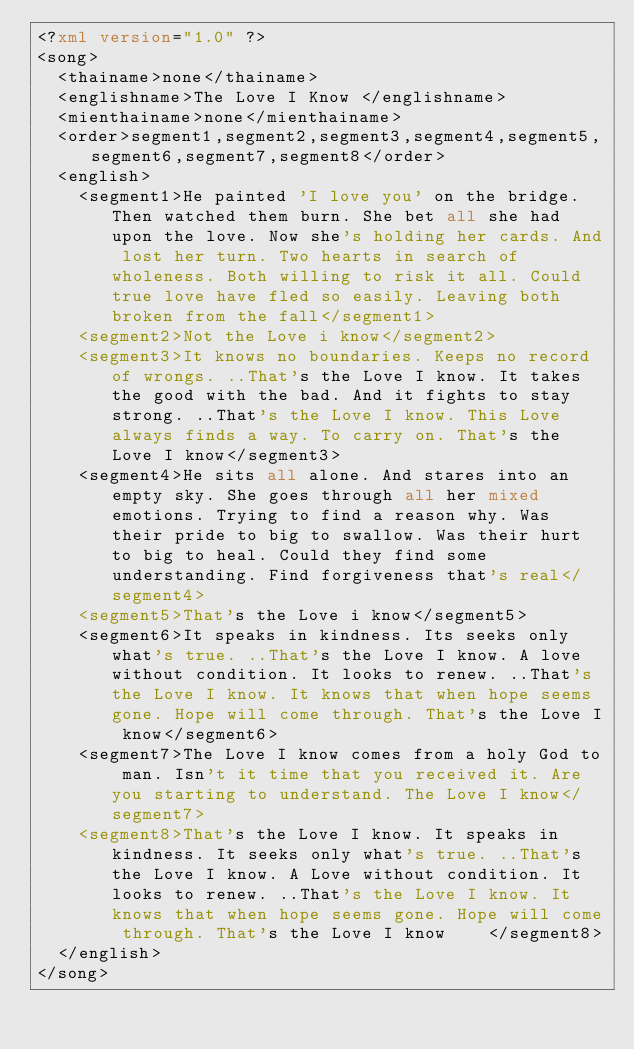Convert code to text. <code><loc_0><loc_0><loc_500><loc_500><_XML_><?xml version="1.0" ?>
<song>
	<thainame>none</thainame>
	<englishname>The Love I Know </englishname>
	<mienthainame>none</mienthainame>
	<order>segment1,segment2,segment3,segment4,segment5,segment6,segment7,segment8</order>
	<english>
		<segment1>He painted 'I love you' on the bridge. Then watched them burn. She bet all she had upon the love. Now she's holding her cards. And lost her turn. Two hearts in search of wholeness. Both willing to risk it all. Could true love have fled so easily. Leaving both broken from the fall</segment1>
		<segment2>Not the Love i know</segment2>
		<segment3>It knows no boundaries. Keeps no record of wrongs. ..That's the Love I know. It takes the good with the bad. And it fights to stay strong. ..That's the Love I know. This Love always finds a way. To carry on. That's the Love I know</segment3>
		<segment4>He sits all alone. And stares into an empty sky. She goes through all her mixed emotions. Trying to find a reason why. Was their pride to big to swallow. Was their hurt to big to heal. Could they find some understanding. Find forgiveness that's real</segment4>
		<segment5>That's the Love i know</segment5>
		<segment6>It speaks in kindness. Its seeks only what's true. ..That's the Love I know. A love without condition. It looks to renew. ..That's the Love I know. It knows that when hope seems gone. Hope will come through. That's the Love I know</segment6>
		<segment7>The Love I know comes from a holy God to man. Isn't it time that you received it. Are you starting to understand. The Love I know</segment7>
		<segment8>That's the Love I know. It speaks in kindness. It seeks only what's true. ..That's the Love I know. A Love without condition. It looks to renew. ..That's the Love I know. It knows that when hope seems gone. Hope will come through. That's the Love I know    </segment8>
	</english>
</song>
</code> 